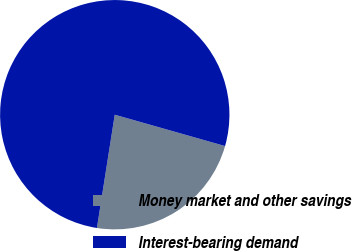<chart> <loc_0><loc_0><loc_500><loc_500><pie_chart><fcel>Money market and other savings<fcel>Interest-bearing demand<nl><fcel>23.08%<fcel>76.92%<nl></chart> 